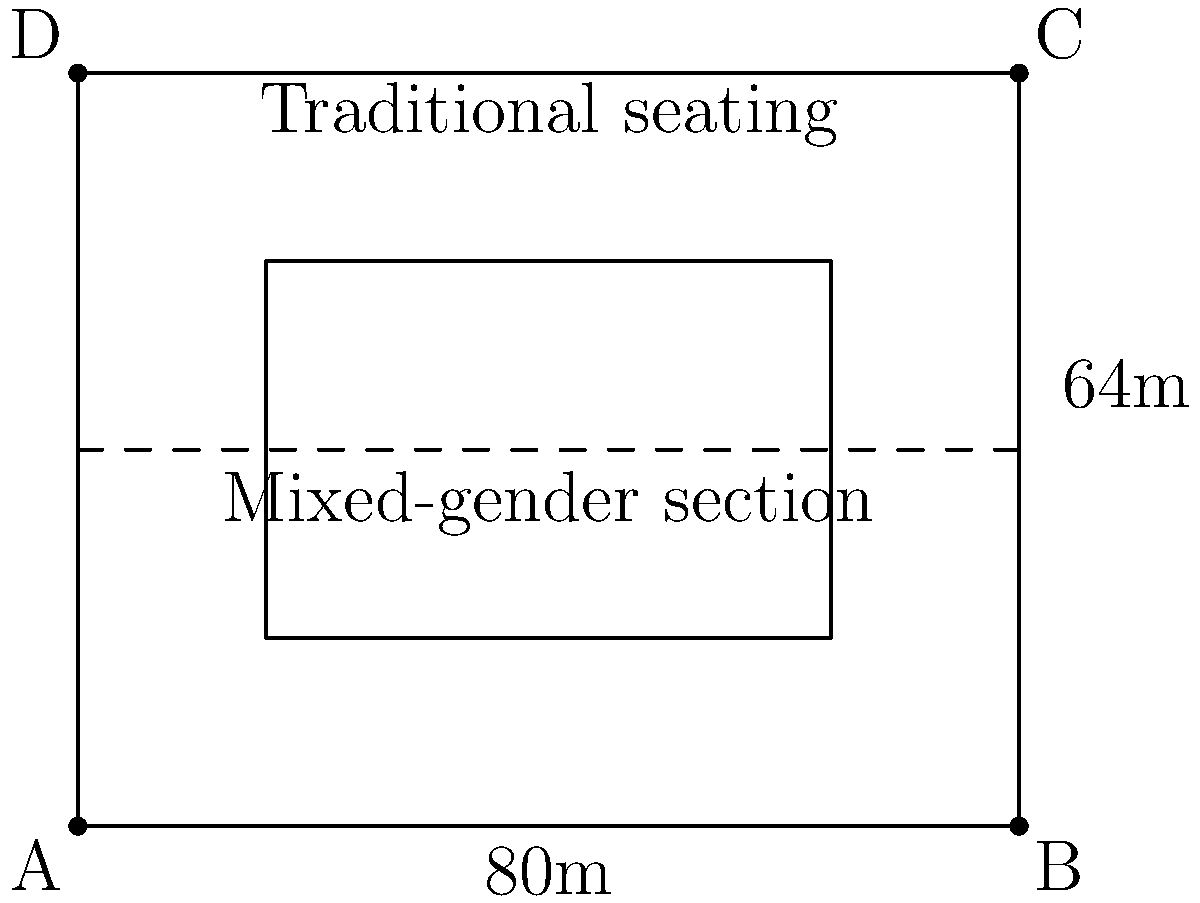A traditional stadium with dimensions 80m x 64m is introducing a mixed-gender seating section in the center, taking up 25% of the total area. If the mixed-gender section is placed symmetrically in the middle of the stadium, what is the width of the remaining traditional seating areas on either side? To solve this problem, we need to follow these steps:

1. Calculate the total area of the stadium:
   Area = length × width = 80m × 64m = 5120 m²

2. Calculate the area of the mixed-gender section:
   Mixed-gender area = 25% of total area = 0.25 × 5120 m² = 1280 m²

3. Calculate the width of the mixed-gender section:
   Let x be the width of the mixed-gender section.
   Area of mixed-gender section = length × width
   1280 m² = 64m × x
   x = 1280 m² ÷ 64m = 20m

4. Calculate the remaining width for traditional seating:
   Total width - Mixed-gender section width = Remaining width
   80m - 20m = 60m

5. Divide the remaining width by 2 to get the width on each side:
   60m ÷ 2 = 30m

Therefore, the width of the remaining traditional seating areas on either side is 30m.
Answer: 30m 